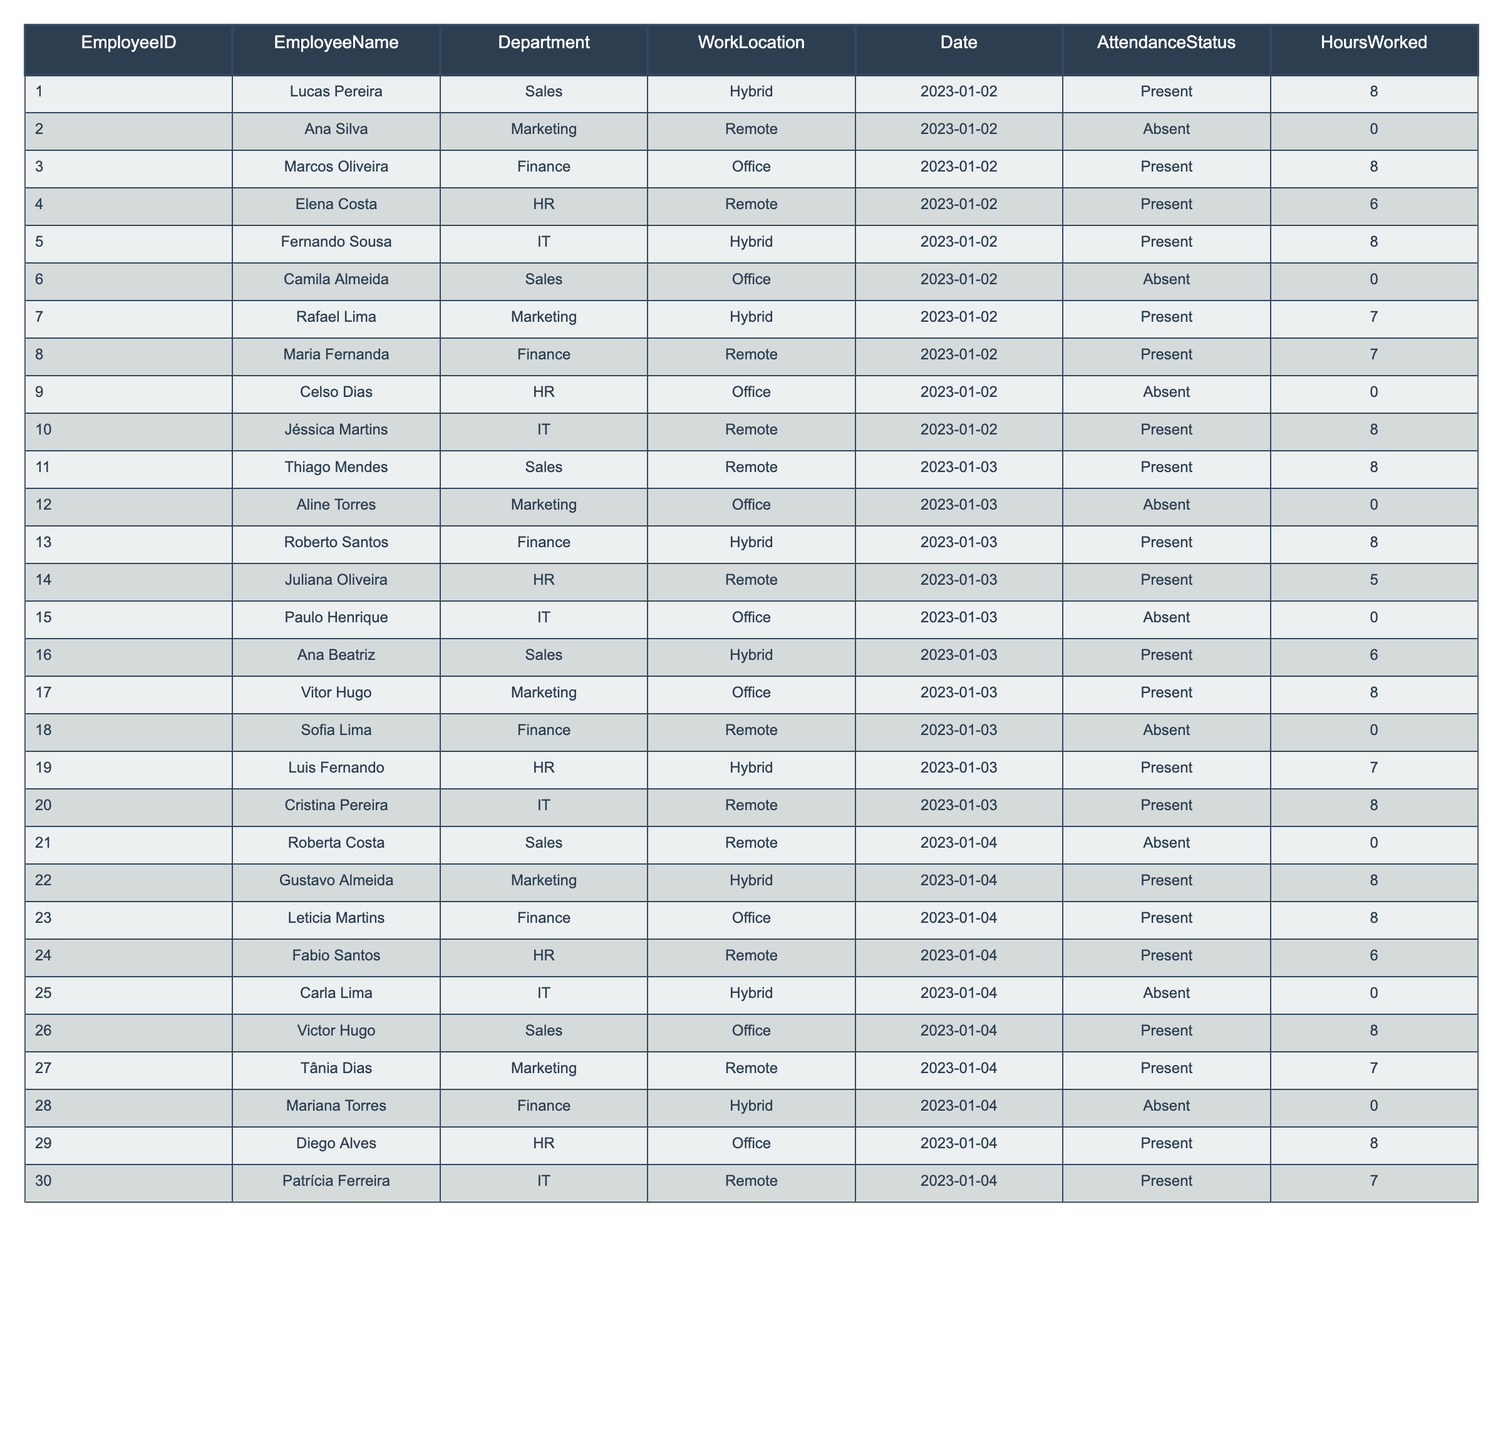What's the attendance status of Ana Silva on January 2nd, 2023? The table shows that Ana Silva was Absent on that date.
Answer: Absent How many hours did Lucas Pereira work on January 2nd, 2023? The table indicates that Lucas Pereira worked 8 hours on January 2nd.
Answer: 8 hours Which employee had the highest hours worked on January 3rd, 2023? Roberto Santos, Marcos Oliveira, and Thiago Mendes each worked 8 hours, which is the highest recorded for that day.
Answer: 8 hours Is there any employee who was present on both January 2nd and January 3rd? Checking the attendance records, Lucas Pereira was Present on January 2nd and Thiago Mendes was Present on January 3rd, but not on the same day.
Answer: No What is the difference in hours worked between Rafael Lima on January 2nd and Luis Fernando on January 3rd? Rafael Lima worked 7 hours on January 2nd, and Luis Fernando worked 7 hours on January 3rd, so the difference is 7 - 7 = 0.
Answer: 0 hours How many employees worked in the office on January 4th, 2023? The table shows that Leticia Martins, Diego Alves, and Victor Hugo worked in the office on that date. Hence, there are 3 employees.
Answer: 3 employees What percentage of employees were absent on January 3rd? On January 3rd, there were 20 employees, and out of them, 4 were absent (Aline Torres, Sofia Lima, and Paulo Henrique), so the percentage of absent employees is (4/20) * 100 = 20%.
Answer: 20% Which department had the most employees present on January 2nd, 2023? Counting the presence, the Sales department had 2 present employees (Lucas Pereira and Camila Almeida). The combinations show that both Marketing and Finance had 2 employees also present. Hence, there is a tie among these departments.
Answer: Tie among Sales, Marketing, and Finance What was the average hours worked by employees in the HR department on January 3rd? Juliana Oliveira worked 5 hours and Luis Fernando worked 7 hours, so the average is (5 + 7) / 2 = 6 hours.
Answer: 6 hours On which date did Carla Lima have hours worked logged? The table indicates that Carla Lima had 0 hours recorded for January 4th, meaning she was absent on that day. There are no entries for her under other dates.
Answer: No hours logged 